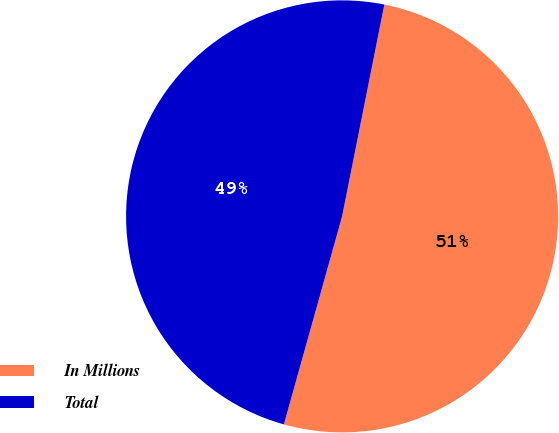Convert chart. <chart><loc_0><loc_0><loc_500><loc_500><pie_chart><fcel>In Millions<fcel>Total<nl><fcel>51.21%<fcel>48.79%<nl></chart> 